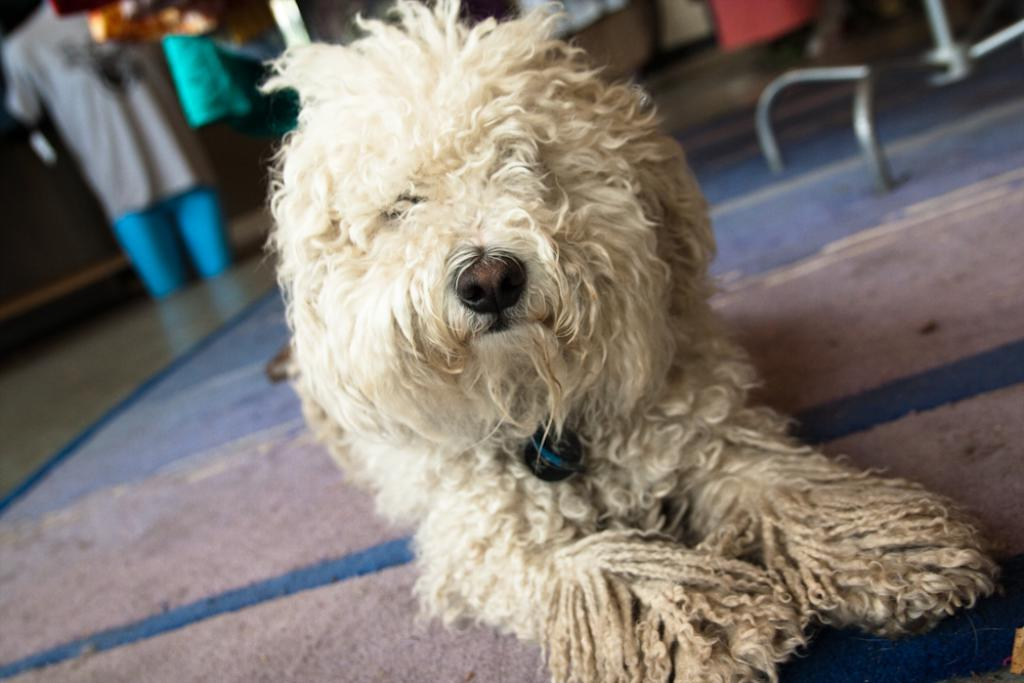What animal can be seen in the image? There is a dog in the image. What is the dog doing in the image? The dog is lying on a mat. What can be seen in the background of the image? There are rods, the floor, cloths, and other objects visible in the background. What type of road can be seen in the image? There is no road present in the image; it features a dog lying on a mat with various objects in the background. Can you tell me how many veins are visible on the dog's body in the image? There is no visible vein on the dog's body in the image; it is not possible to determine the number of veins. 